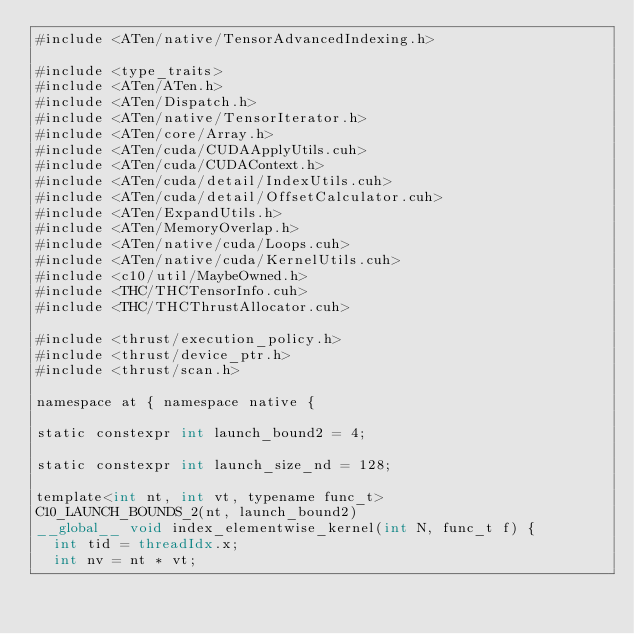Convert code to text. <code><loc_0><loc_0><loc_500><loc_500><_Cuda_>#include <ATen/native/TensorAdvancedIndexing.h>

#include <type_traits>
#include <ATen/ATen.h>
#include <ATen/Dispatch.h>
#include <ATen/native/TensorIterator.h>
#include <ATen/core/Array.h>
#include <ATen/cuda/CUDAApplyUtils.cuh>
#include <ATen/cuda/CUDAContext.h>
#include <ATen/cuda/detail/IndexUtils.cuh>
#include <ATen/cuda/detail/OffsetCalculator.cuh>
#include <ATen/ExpandUtils.h>
#include <ATen/MemoryOverlap.h>
#include <ATen/native/cuda/Loops.cuh>
#include <ATen/native/cuda/KernelUtils.cuh>
#include <c10/util/MaybeOwned.h>
#include <THC/THCTensorInfo.cuh>
#include <THC/THCThrustAllocator.cuh>

#include <thrust/execution_policy.h>
#include <thrust/device_ptr.h>
#include <thrust/scan.h>

namespace at { namespace native {

static constexpr int launch_bound2 = 4;

static constexpr int launch_size_nd = 128;

template<int nt, int vt, typename func_t>
C10_LAUNCH_BOUNDS_2(nt, launch_bound2)
__global__ void index_elementwise_kernel(int N, func_t f) {
  int tid = threadIdx.x;
  int nv = nt * vt;</code> 